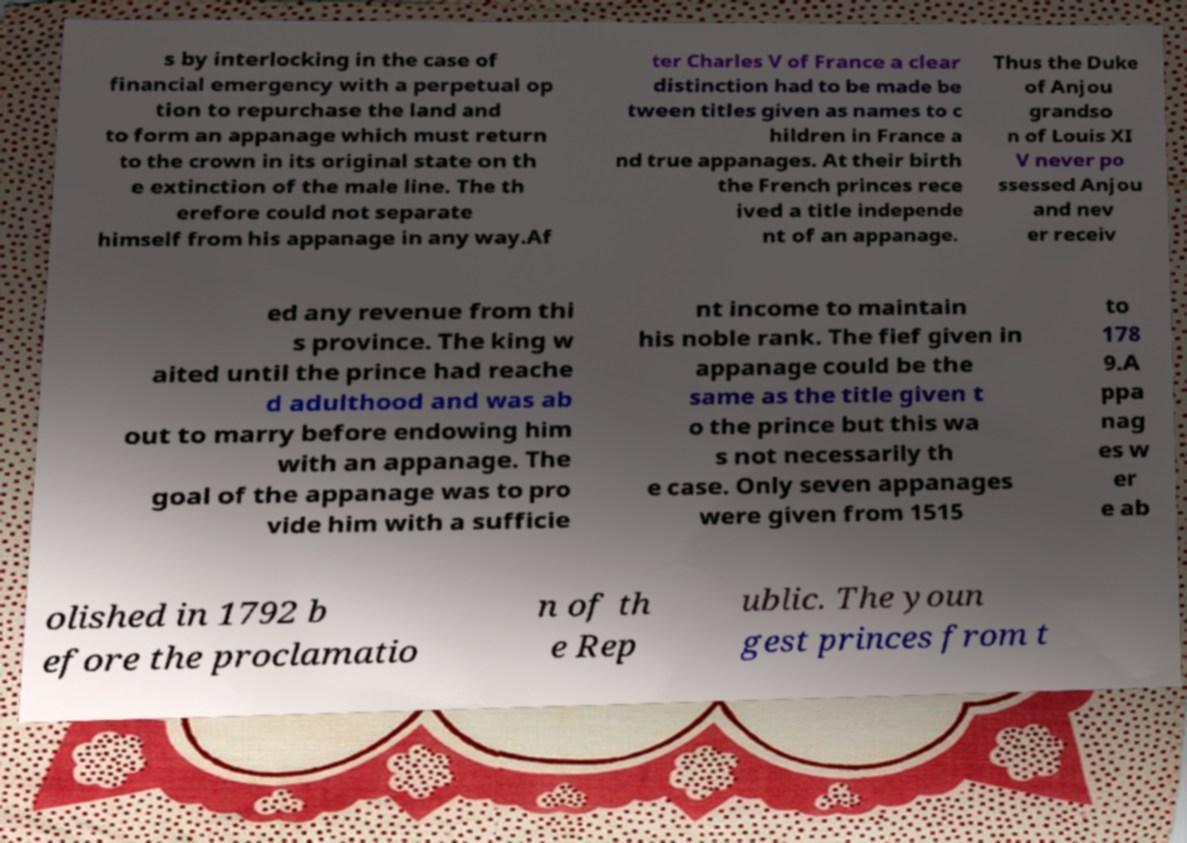Could you extract and type out the text from this image? s by interlocking in the case of financial emergency with a perpetual op tion to repurchase the land and to form an appanage which must return to the crown in its original state on th e extinction of the male line. The th erefore could not separate himself from his appanage in any way.Af ter Charles V of France a clear distinction had to be made be tween titles given as names to c hildren in France a nd true appanages. At their birth the French princes rece ived a title independe nt of an appanage. Thus the Duke of Anjou grandso n of Louis XI V never po ssessed Anjou and nev er receiv ed any revenue from thi s province. The king w aited until the prince had reache d adulthood and was ab out to marry before endowing him with an appanage. The goal of the appanage was to pro vide him with a sufficie nt income to maintain his noble rank. The fief given in appanage could be the same as the title given t o the prince but this wa s not necessarily th e case. Only seven appanages were given from 1515 to 178 9.A ppa nag es w er e ab olished in 1792 b efore the proclamatio n of th e Rep ublic. The youn gest princes from t 